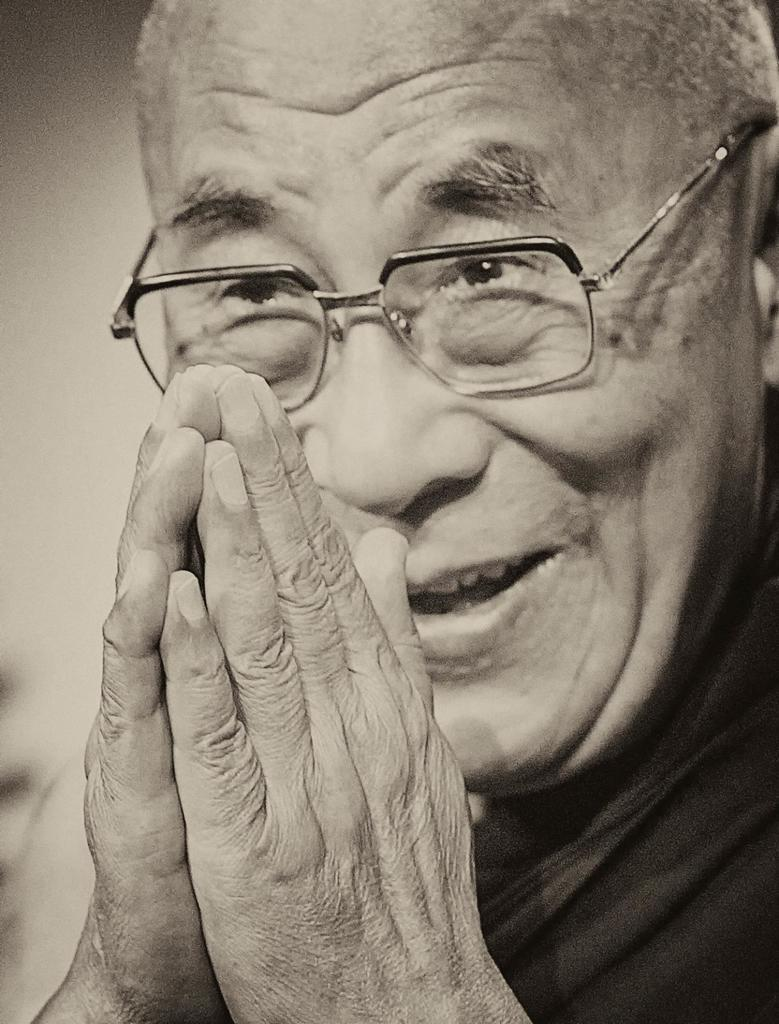What is the main subject of the picture? The main subject of the picture is a man. What is the man doing in the picture? The man is smiling and holding his hands together. What type of corn is being sold in the picture? There is no corn present in the picture; it features a man who is smiling and holding his hands together. What is the man's profit margin in the picture? There is no information about profit margins in the picture, as it only shows a man smiling and holding his hands together. 